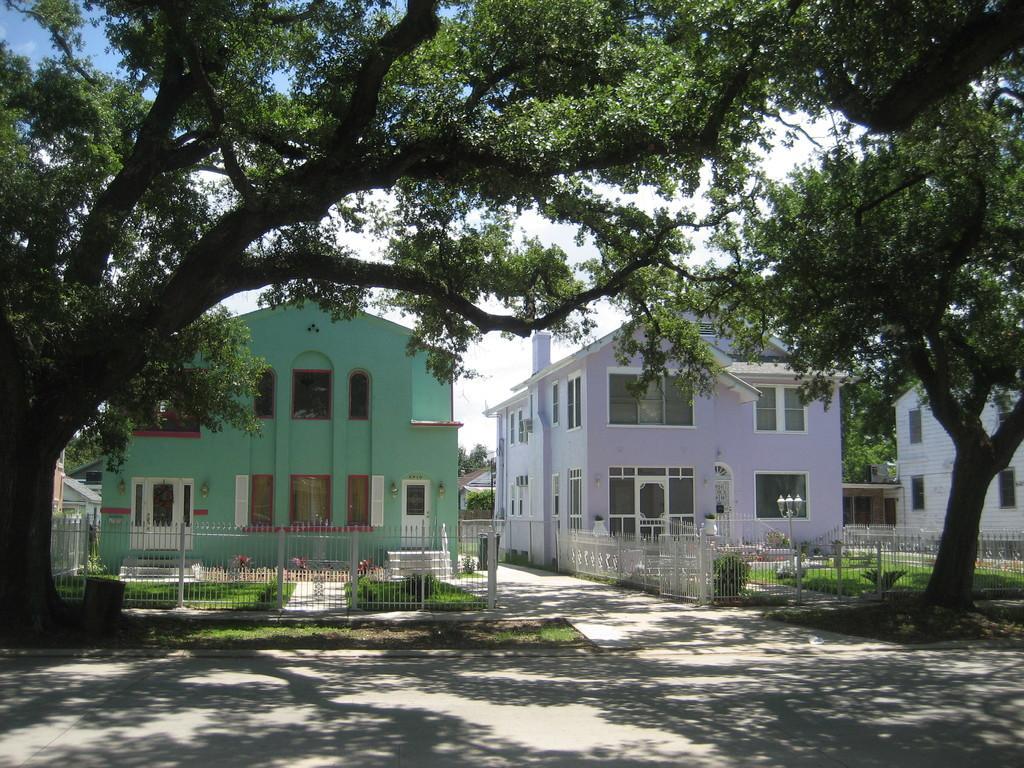Describe this image in one or two sentences. In the center of the image there are buildings. At the bottom we can see trees and fence. In the background there is sky. 